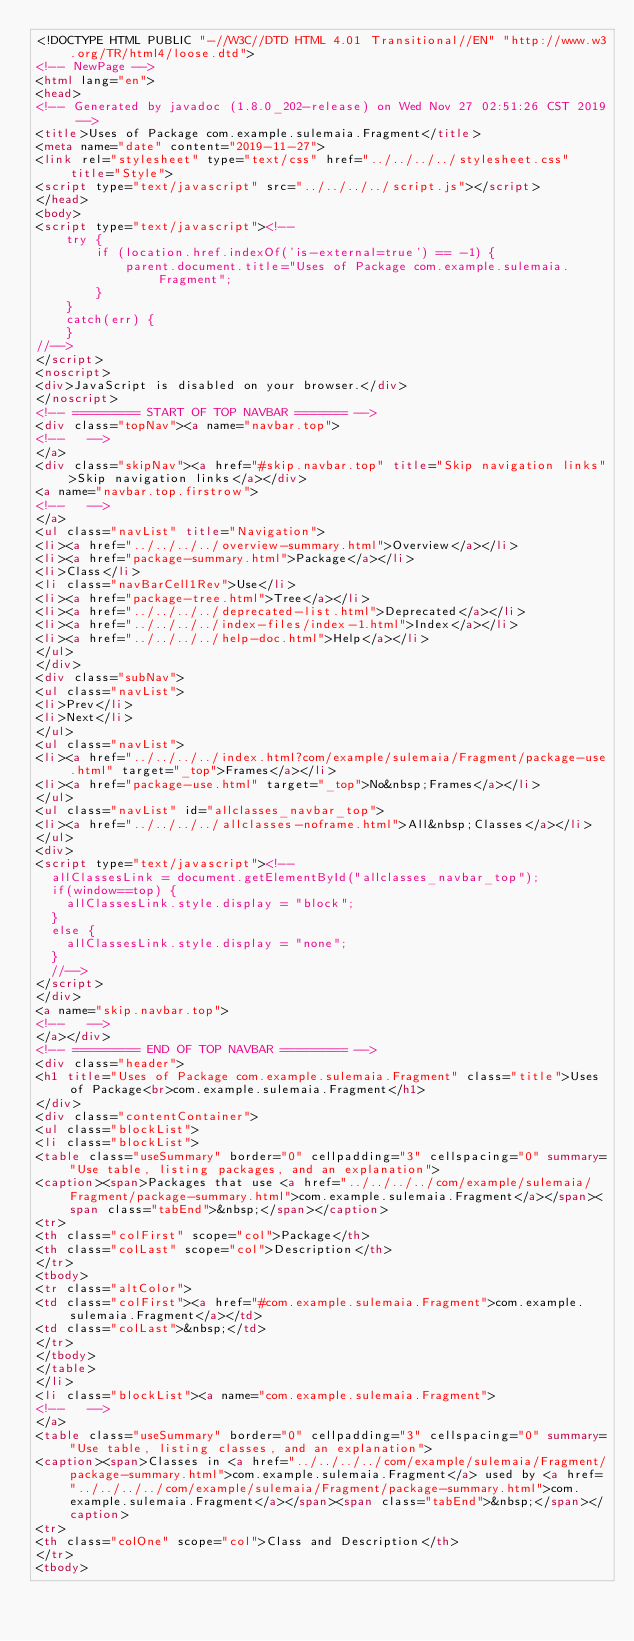<code> <loc_0><loc_0><loc_500><loc_500><_HTML_><!DOCTYPE HTML PUBLIC "-//W3C//DTD HTML 4.01 Transitional//EN" "http://www.w3.org/TR/html4/loose.dtd">
<!-- NewPage -->
<html lang="en">
<head>
<!-- Generated by javadoc (1.8.0_202-release) on Wed Nov 27 02:51:26 CST 2019 -->
<title>Uses of Package com.example.sulemaia.Fragment</title>
<meta name="date" content="2019-11-27">
<link rel="stylesheet" type="text/css" href="../../../../stylesheet.css" title="Style">
<script type="text/javascript" src="../../../../script.js"></script>
</head>
<body>
<script type="text/javascript"><!--
    try {
        if (location.href.indexOf('is-external=true') == -1) {
            parent.document.title="Uses of Package com.example.sulemaia.Fragment";
        }
    }
    catch(err) {
    }
//-->
</script>
<noscript>
<div>JavaScript is disabled on your browser.</div>
</noscript>
<!-- ========= START OF TOP NAVBAR ======= -->
<div class="topNav"><a name="navbar.top">
<!--   -->
</a>
<div class="skipNav"><a href="#skip.navbar.top" title="Skip navigation links">Skip navigation links</a></div>
<a name="navbar.top.firstrow">
<!--   -->
</a>
<ul class="navList" title="Navigation">
<li><a href="../../../../overview-summary.html">Overview</a></li>
<li><a href="package-summary.html">Package</a></li>
<li>Class</li>
<li class="navBarCell1Rev">Use</li>
<li><a href="package-tree.html">Tree</a></li>
<li><a href="../../../../deprecated-list.html">Deprecated</a></li>
<li><a href="../../../../index-files/index-1.html">Index</a></li>
<li><a href="../../../../help-doc.html">Help</a></li>
</ul>
</div>
<div class="subNav">
<ul class="navList">
<li>Prev</li>
<li>Next</li>
</ul>
<ul class="navList">
<li><a href="../../../../index.html?com/example/sulemaia/Fragment/package-use.html" target="_top">Frames</a></li>
<li><a href="package-use.html" target="_top">No&nbsp;Frames</a></li>
</ul>
<ul class="navList" id="allclasses_navbar_top">
<li><a href="../../../../allclasses-noframe.html">All&nbsp;Classes</a></li>
</ul>
<div>
<script type="text/javascript"><!--
  allClassesLink = document.getElementById("allclasses_navbar_top");
  if(window==top) {
    allClassesLink.style.display = "block";
  }
  else {
    allClassesLink.style.display = "none";
  }
  //-->
</script>
</div>
<a name="skip.navbar.top">
<!--   -->
</a></div>
<!-- ========= END OF TOP NAVBAR ========= -->
<div class="header">
<h1 title="Uses of Package com.example.sulemaia.Fragment" class="title">Uses of Package<br>com.example.sulemaia.Fragment</h1>
</div>
<div class="contentContainer">
<ul class="blockList">
<li class="blockList">
<table class="useSummary" border="0" cellpadding="3" cellspacing="0" summary="Use table, listing packages, and an explanation">
<caption><span>Packages that use <a href="../../../../com/example/sulemaia/Fragment/package-summary.html">com.example.sulemaia.Fragment</a></span><span class="tabEnd">&nbsp;</span></caption>
<tr>
<th class="colFirst" scope="col">Package</th>
<th class="colLast" scope="col">Description</th>
</tr>
<tbody>
<tr class="altColor">
<td class="colFirst"><a href="#com.example.sulemaia.Fragment">com.example.sulemaia.Fragment</a></td>
<td class="colLast">&nbsp;</td>
</tr>
</tbody>
</table>
</li>
<li class="blockList"><a name="com.example.sulemaia.Fragment">
<!--   -->
</a>
<table class="useSummary" border="0" cellpadding="3" cellspacing="0" summary="Use table, listing classes, and an explanation">
<caption><span>Classes in <a href="../../../../com/example/sulemaia/Fragment/package-summary.html">com.example.sulemaia.Fragment</a> used by <a href="../../../../com/example/sulemaia/Fragment/package-summary.html">com.example.sulemaia.Fragment</a></span><span class="tabEnd">&nbsp;</span></caption>
<tr>
<th class="colOne" scope="col">Class and Description</th>
</tr>
<tbody></code> 